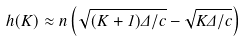Convert formula to latex. <formula><loc_0><loc_0><loc_500><loc_500>h ( K ) \approx n \left ( \sqrt { ( K + 1 ) \Delta / c } - \sqrt { K \Delta / c } \right )</formula> 